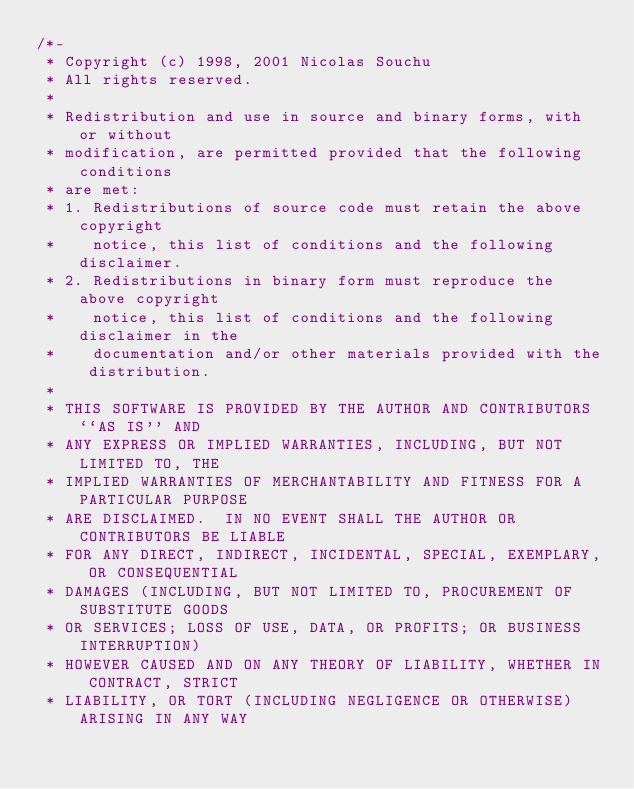<code> <loc_0><loc_0><loc_500><loc_500><_C_>/*-
 * Copyright (c) 1998, 2001 Nicolas Souchu
 * All rights reserved.
 *
 * Redistribution and use in source and binary forms, with or without
 * modification, are permitted provided that the following conditions
 * are met:
 * 1. Redistributions of source code must retain the above copyright
 *    notice, this list of conditions and the following disclaimer.
 * 2. Redistributions in binary form must reproduce the above copyright
 *    notice, this list of conditions and the following disclaimer in the
 *    documentation and/or other materials provided with the distribution.
 *
 * THIS SOFTWARE IS PROVIDED BY THE AUTHOR AND CONTRIBUTORS ``AS IS'' AND
 * ANY EXPRESS OR IMPLIED WARRANTIES, INCLUDING, BUT NOT LIMITED TO, THE
 * IMPLIED WARRANTIES OF MERCHANTABILITY AND FITNESS FOR A PARTICULAR PURPOSE
 * ARE DISCLAIMED.  IN NO EVENT SHALL THE AUTHOR OR CONTRIBUTORS BE LIABLE
 * FOR ANY DIRECT, INDIRECT, INCIDENTAL, SPECIAL, EXEMPLARY, OR CONSEQUENTIAL
 * DAMAGES (INCLUDING, BUT NOT LIMITED TO, PROCUREMENT OF SUBSTITUTE GOODS
 * OR SERVICES; LOSS OF USE, DATA, OR PROFITS; OR BUSINESS INTERRUPTION)
 * HOWEVER CAUSED AND ON ANY THEORY OF LIABILITY, WHETHER IN CONTRACT, STRICT
 * LIABILITY, OR TORT (INCLUDING NEGLIGENCE OR OTHERWISE) ARISING IN ANY WAY</code> 